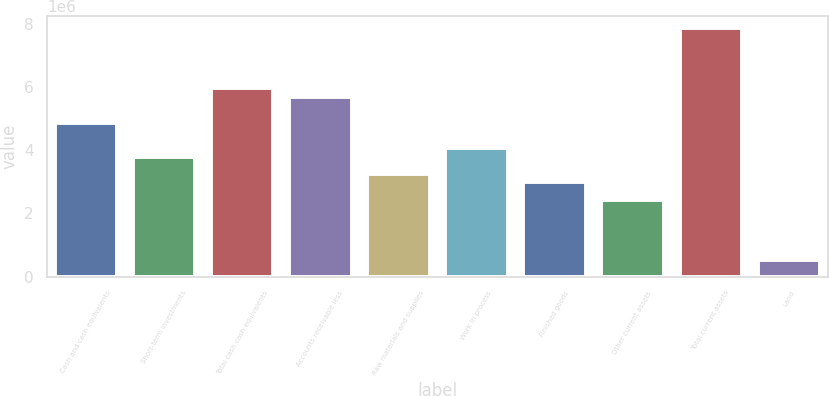<chart> <loc_0><loc_0><loc_500><loc_500><bar_chart><fcel>Cash and cash equivalents<fcel>Short-term investments<fcel>Total cash cash equivalents<fcel>Accounts receivable less<fcel>Raw materials and supplies<fcel>Work in process<fcel>Finished goods<fcel>Other current assets<fcel>Total current assets<fcel>Land<nl><fcel>4.87232e+06<fcel>3.78962e+06<fcel>5.95502e+06<fcel>5.68435e+06<fcel>3.24827e+06<fcel>4.06029e+06<fcel>2.97759e+06<fcel>2.43624e+06<fcel>7.84975e+06<fcel>541511<nl></chart> 